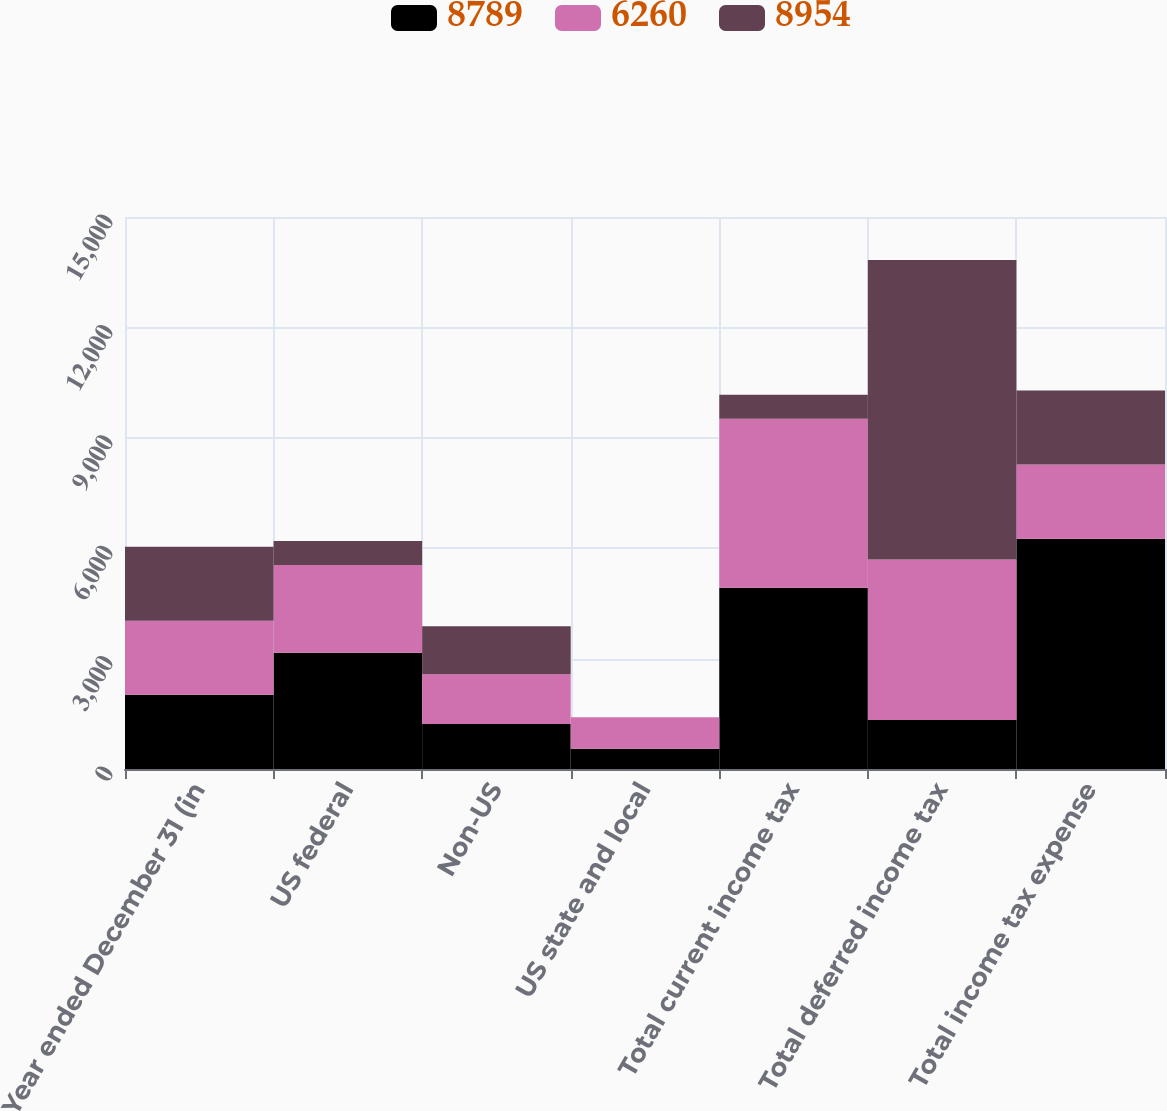Convert chart. <chart><loc_0><loc_0><loc_500><loc_500><stacked_bar_chart><ecel><fcel>Year ended December 31 (in<fcel>US federal<fcel>Non-US<fcel>US state and local<fcel>Total current income tax<fcel>Total deferred income tax<fcel>Total income tax expense<nl><fcel>8789<fcel>2015<fcel>3160<fcel>1220<fcel>547<fcel>4927<fcel>1333<fcel>6260<nl><fcel>6260<fcel>2014<fcel>2382<fcel>1353<fcel>857<fcel>4592<fcel>4362<fcel>2013<nl><fcel>8954<fcel>2013<fcel>654<fcel>1308<fcel>4<fcel>650<fcel>8139<fcel>2013<nl></chart> 